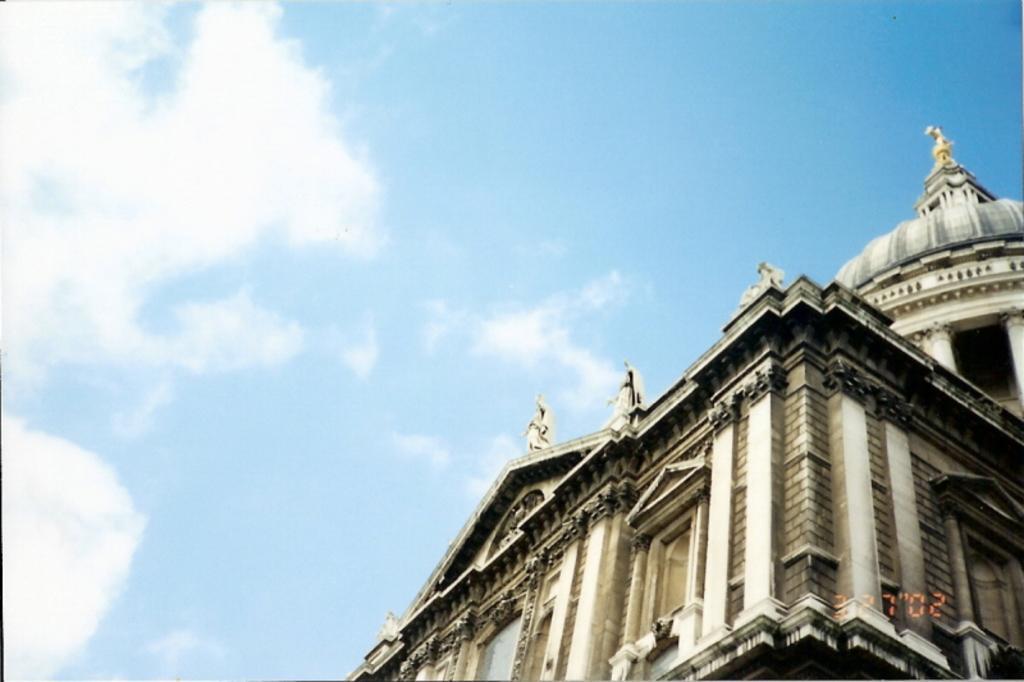Could you give a brief overview of what you see in this image? In this image we can see a building, statues on the building and clouds in the sky. 